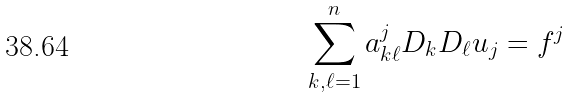<formula> <loc_0><loc_0><loc_500><loc_500>\sum _ { k , \ell = 1 } ^ { n } a _ { k \ell } ^ { j } D _ { k } D _ { \ell } u _ { j } = f ^ { j }</formula> 